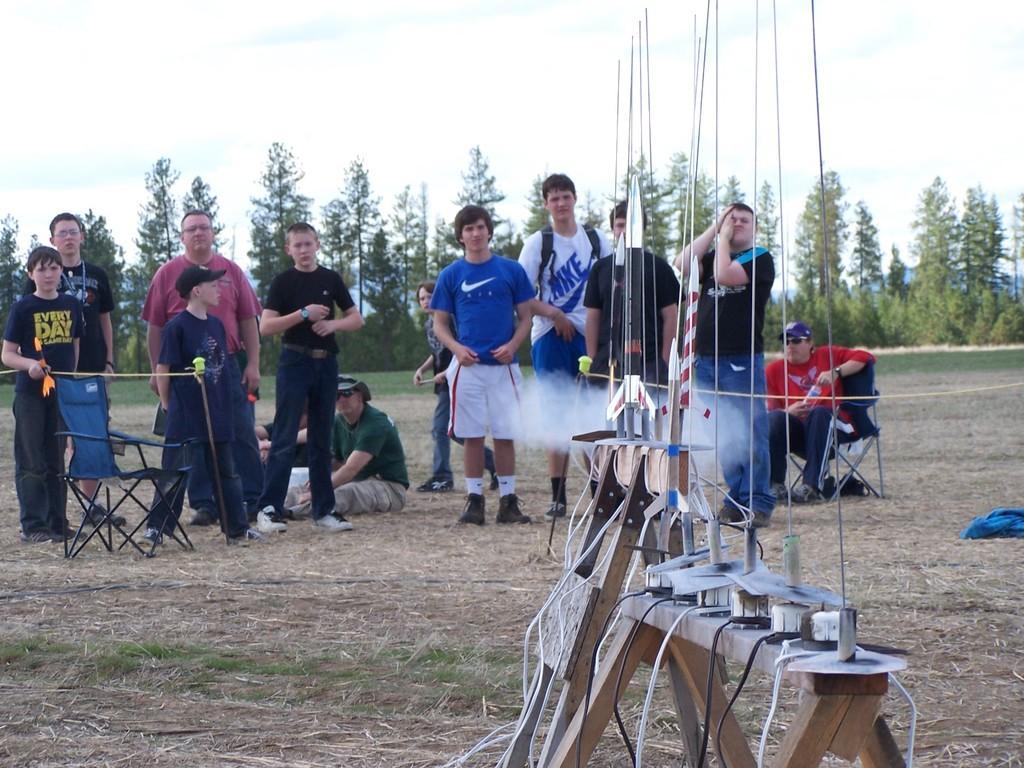Please provide a concise description of this image. In the foreground I can see an aircraft equipment on the ground. In the background, I can see a few persons standing on the ground and they are having a look at the aircraft. I can see two persons sitting on the ground and a man sitting on the chair. In the background, I can see the trees. 